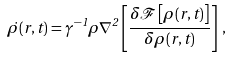<formula> <loc_0><loc_0><loc_500><loc_500>\dot { \rho } ( { r } , t ) = \gamma ^ { - 1 } \rho \nabla ^ { 2 } \left [ \frac { \delta { \mathcal { F } } \left [ \rho ( { r } , t ) \right ] } { \delta \rho ( { r } , t ) } \right ] \, ,</formula> 